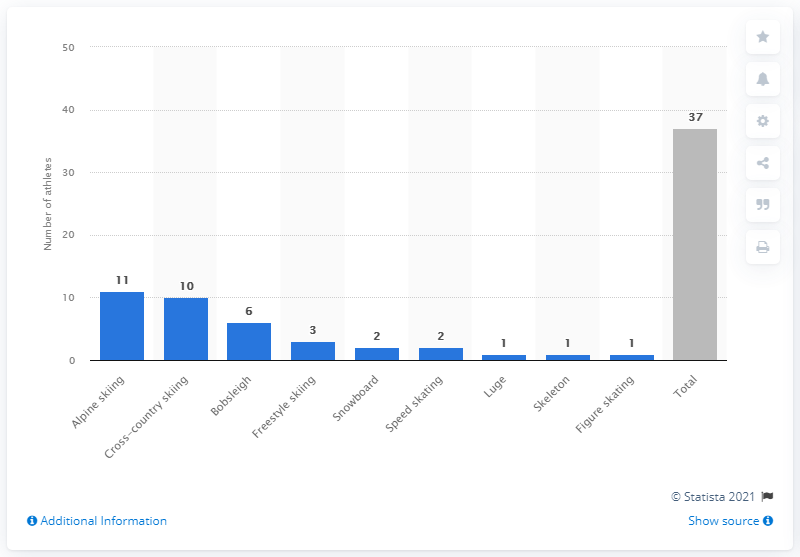Give some essential details in this illustration. During the PyeongChang Winter Games, 37 athletes from Latin America and the Caribbean participated and showcased their skills. 